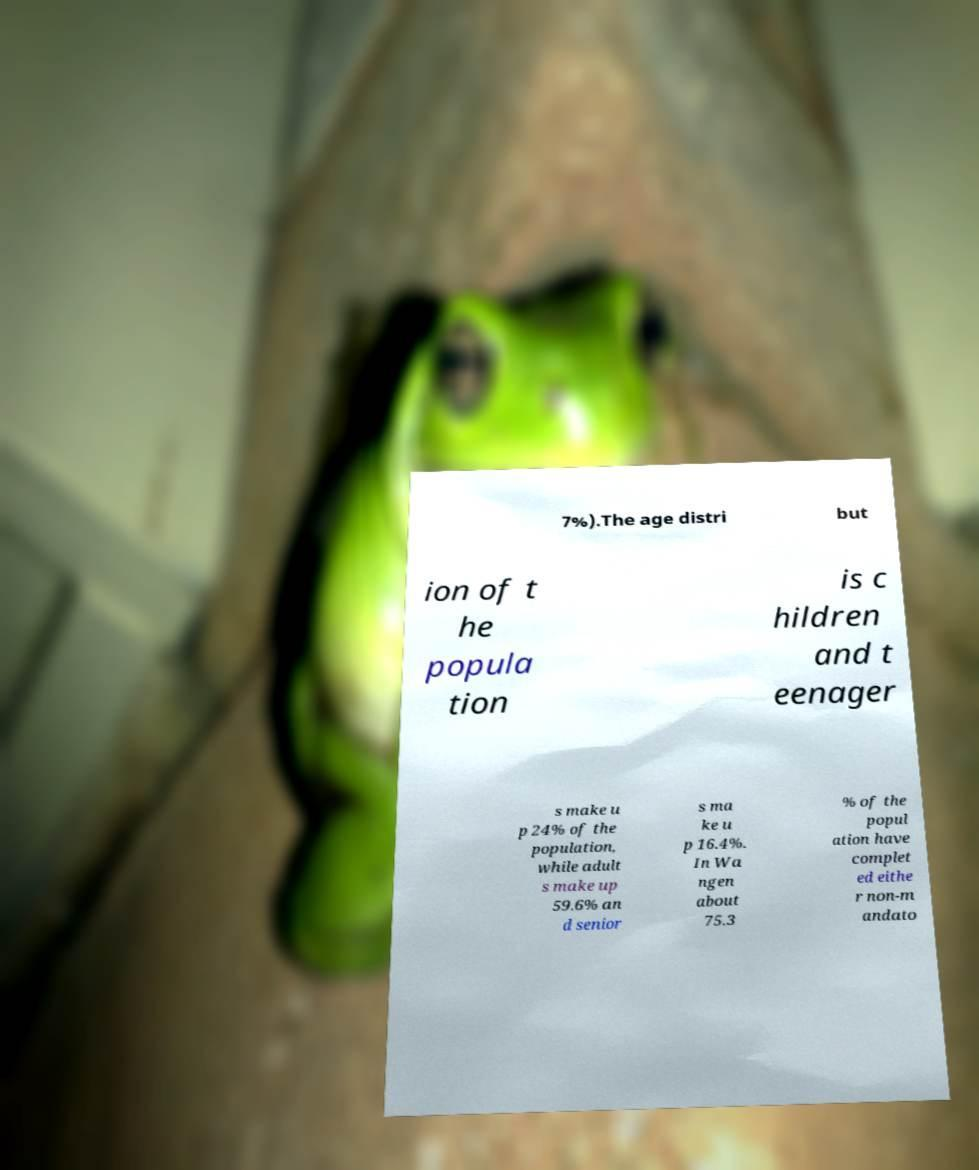Please identify and transcribe the text found in this image. 7%).The age distri but ion of t he popula tion is c hildren and t eenager s make u p 24% of the population, while adult s make up 59.6% an d senior s ma ke u p 16.4%. In Wa ngen about 75.3 % of the popul ation have complet ed eithe r non-m andato 